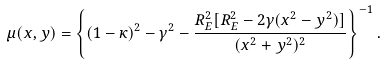Convert formula to latex. <formula><loc_0><loc_0><loc_500><loc_500>\mu ( x , y ) = \left \{ ( 1 - \kappa ) ^ { 2 } - \gamma ^ { 2 } - \frac { R _ { E } ^ { 2 } [ R _ { E } ^ { 2 } - 2 \gamma ( x ^ { 2 } - y ^ { 2 } ) ] } { ( x ^ { 2 } + y ^ { 2 } ) ^ { 2 } } \right \} ^ { - 1 } .</formula> 